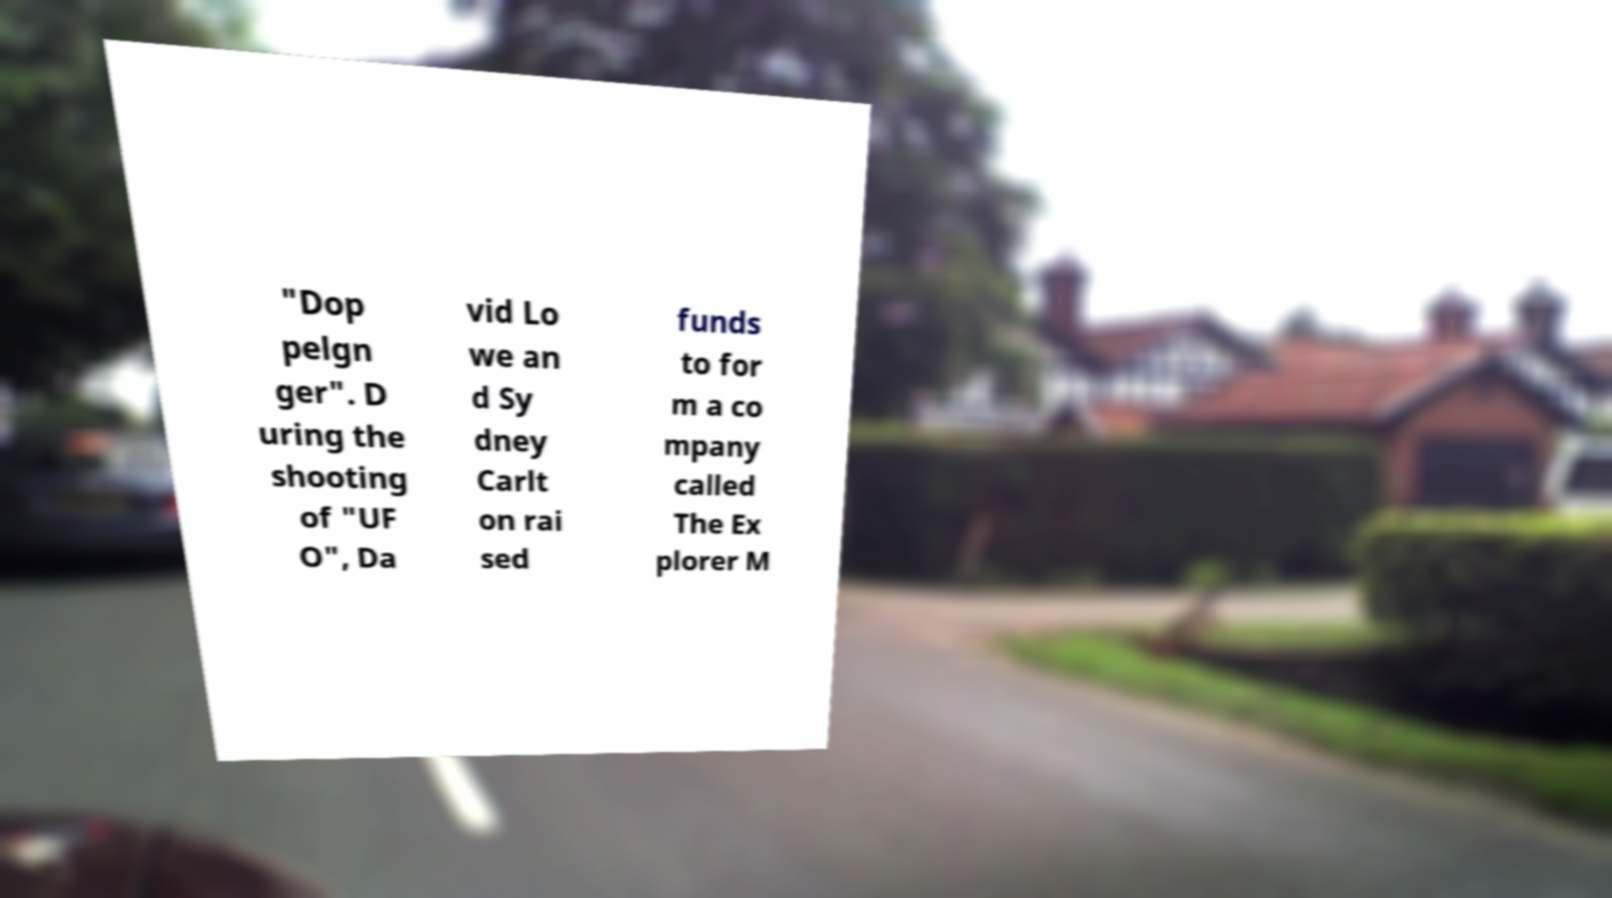Please identify and transcribe the text found in this image. "Dop pelgn ger". D uring the shooting of "UF O", Da vid Lo we an d Sy dney Carlt on rai sed funds to for m a co mpany called The Ex plorer M 